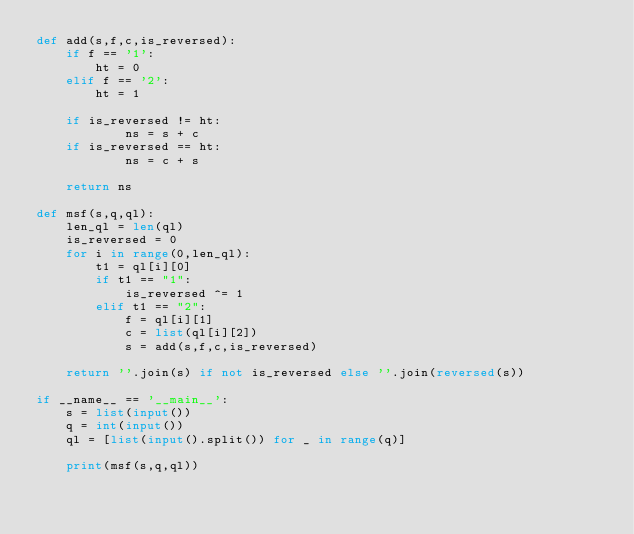Convert code to text. <code><loc_0><loc_0><loc_500><loc_500><_Python_>def add(s,f,c,is_reversed):
    if f == '1':
        ht = 0
    elif f == '2':
        ht = 1
        
    if is_reversed != ht:
            ns = s + c 
    if is_reversed == ht:
            ns = c + s

    return ns

def msf(s,q,ql):
    len_ql = len(ql)
    is_reversed = 0
    for i in range(0,len_ql):
        t1 = ql[i][0]
        if t1 == "1":
            is_reversed ^= 1
        elif t1 == "2":
            f = ql[i][1]
            c = list(ql[i][2])
            s = add(s,f,c,is_reversed)

    return ''.join(s) if not is_reversed else ''.join(reversed(s))
    
if __name__ == '__main__':
    s = list(input())
    q = int(input())
    ql = [list(input().split()) for _ in range(q)]
    
    print(msf(s,q,ql))
</code> 